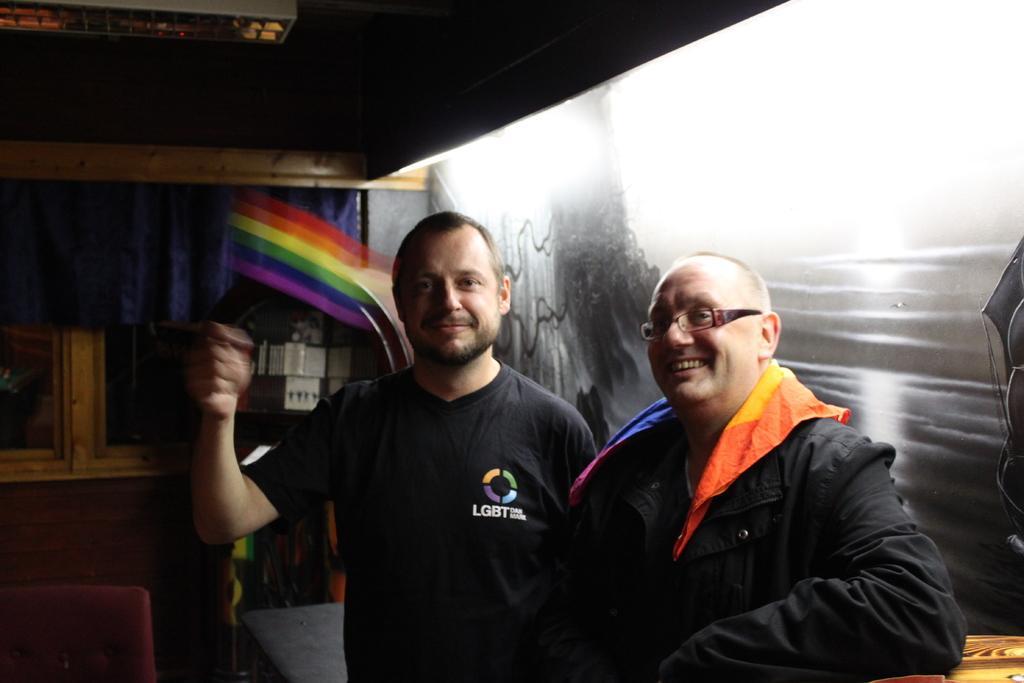Please provide a concise description of this image. On the right side, there are two persons in black color dresses, smiling and standing. One of them is keeping his elbow on a surface. In the background, there is a curtain, there is a glass window and there are other objects. 